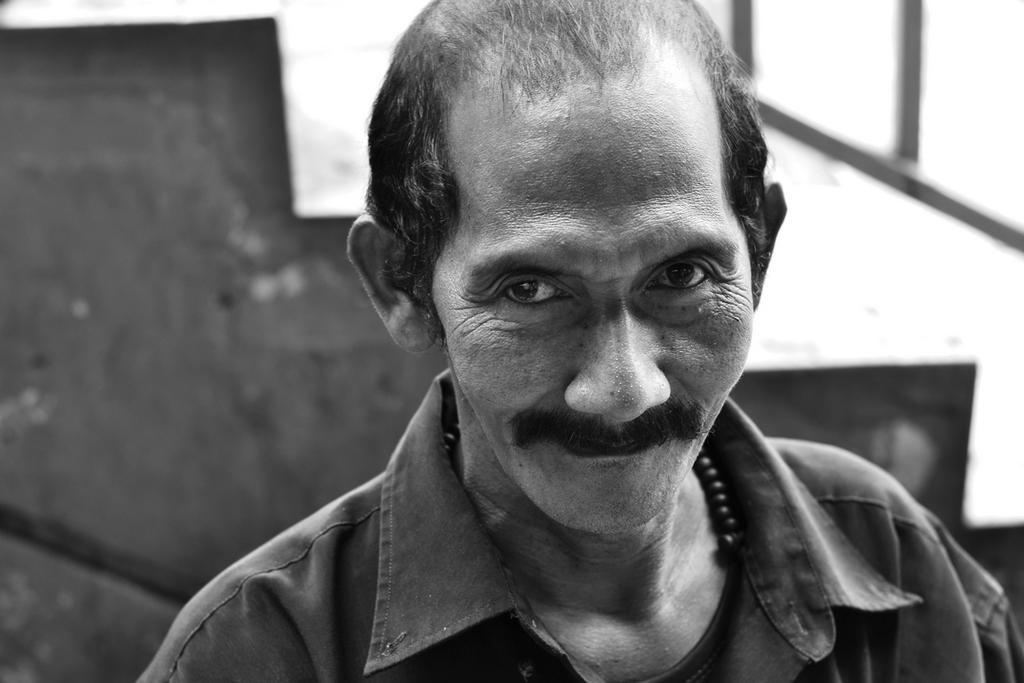Could you give a brief overview of what you see in this image? This is a black and white image. A man is present wearing a shirt. There are stairs at the back. 